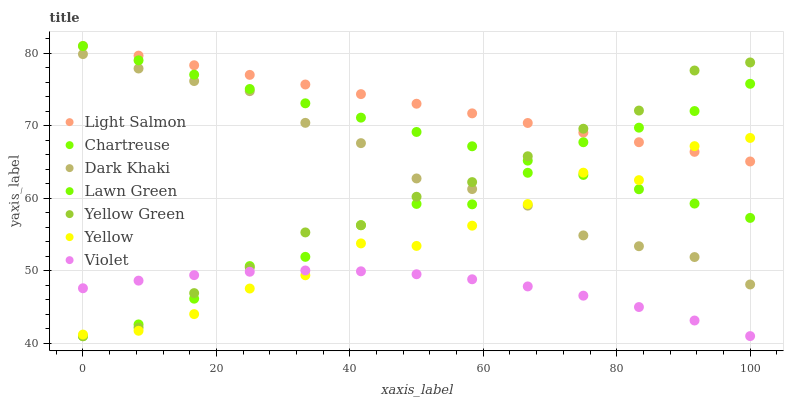Does Violet have the minimum area under the curve?
Answer yes or no. Yes. Does Light Salmon have the maximum area under the curve?
Answer yes or no. Yes. Does Yellow Green have the minimum area under the curve?
Answer yes or no. No. Does Yellow Green have the maximum area under the curve?
Answer yes or no. No. Is Lawn Green the smoothest?
Answer yes or no. Yes. Is Yellow the roughest?
Answer yes or no. Yes. Is Light Salmon the smoothest?
Answer yes or no. No. Is Light Salmon the roughest?
Answer yes or no. No. Does Yellow Green have the lowest value?
Answer yes or no. Yes. Does Light Salmon have the lowest value?
Answer yes or no. No. Does Light Salmon have the highest value?
Answer yes or no. Yes. Does Yellow Green have the highest value?
Answer yes or no. No. Is Dark Khaki less than Lawn Green?
Answer yes or no. Yes. Is Lawn Green greater than Violet?
Answer yes or no. Yes. Does Yellow intersect Light Salmon?
Answer yes or no. Yes. Is Yellow less than Light Salmon?
Answer yes or no. No. Is Yellow greater than Light Salmon?
Answer yes or no. No. Does Dark Khaki intersect Lawn Green?
Answer yes or no. No. 